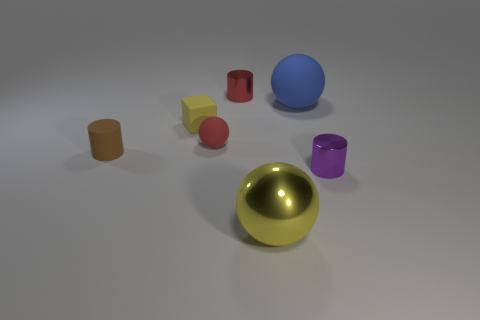The cylinder that is both to the right of the brown rubber cylinder and in front of the blue matte sphere is what color?
Your answer should be compact. Purple. Do the metal object that is to the right of the metallic sphere and the large rubber sphere have the same size?
Make the answer very short. No. Are there more tiny purple metal objects that are behind the big yellow metal sphere than big yellow things?
Ensure brevity in your answer.  No. Do the brown rubber thing and the large matte object have the same shape?
Your answer should be compact. No. What is the size of the yellow matte block?
Make the answer very short. Small. Is the number of yellow blocks in front of the yellow ball greater than the number of yellow metal balls that are to the left of the brown object?
Your answer should be very brief. No. Are there any large shiny spheres on the right side of the red shiny cylinder?
Your answer should be compact. Yes. Are there any blue cubes of the same size as the yellow metallic sphere?
Offer a terse response. No. There is a tiny cylinder that is made of the same material as the yellow cube; what is its color?
Keep it short and to the point. Brown. What material is the yellow ball?
Make the answer very short. Metal. 